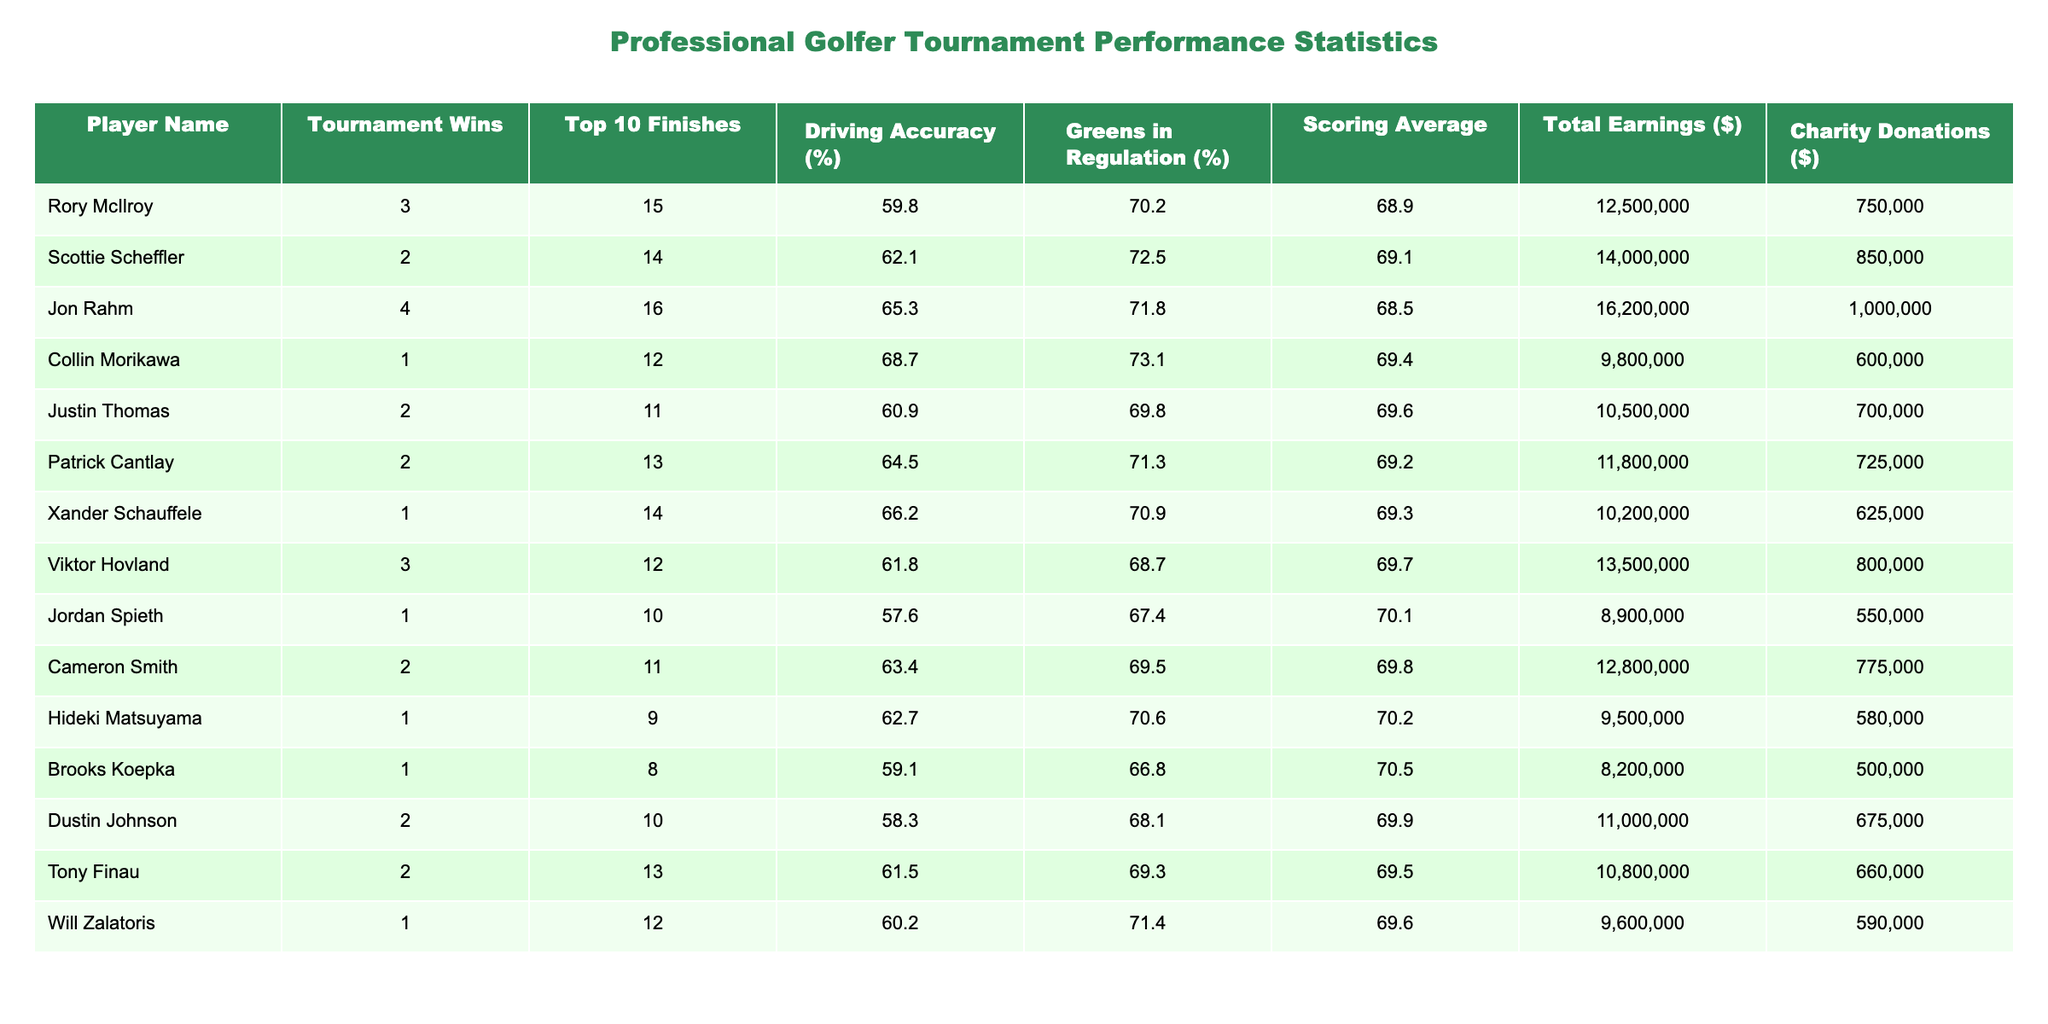What is the player with the highest total earnings? By examining the "Total Earnings ($)" column, Jon Rahm has the highest amount at $16,200,000.
Answer: Jon Rahm How many tournaments did Collin Morikawa win last year? The "Tournament Wins" column for Collin Morikawa shows that he won 1 tournament.
Answer: 1 Which player has the lowest driving accuracy percentage? The "Driving Accuracy (%)" column indicates that Jordan Spieth has the lowest percentage at 57.6%.
Answer: Jordan Spieth What is the average number of charity donations among all players? To find the average, add up all donations ($750,000 + $850,000 + $1,000,000 + $600,000 + $700,000 + $725,000 + $625,000 + $800,000 + $550,000 + $775,000 + $580,000 + $500,000 + $675,000 + $660,000 + $590,000) = $11,725,000. There are 14 players, so $11,725,000 / 14 = $838,214.29, rounded to $838,214.
Answer: $838,214 Did Xander Schauffele finish in the top 10 more times than Collin Morikawa? Xander Schauffele had 14 top 10 finishes while Collin Morikawa had 12. Since 14 is greater than 12, the answer is yes.
Answer: Yes Which player contributed the most to charity among those with three tournament wins? Both Rory McIlroy and Viktor Hovland have three tournament wins. Checking their charity donations, Rory McIlroy donated $750,000, while Viktor Hovland donated $800,000. Thus, Viktor Hovland contributed the most.
Answer: Viktor Hovland What percentage of tournaments won by Jon Rahm corresponds to his total number of tournaments played based on his top 10 finishes? Jon Rahm won 4 tournaments and had 16 top 10 finishes. The percentage of his wins compared to his finishes is (4/16) * 100 = 25%.
Answer: 25% Is there any player who has both a tournament win and a top 10 finish above 15? Checking the table, Jon Rahm has 4 wins and 16 top 10 finishes, fulfilling this criteria.
Answer: Yes What is the scoring average of the player with the highest number of top 10 finishes? Jon Rahm also has the highest number of top 10 finishes at 16, and his scoring average is 68.5.
Answer: 68.5 How many more top 10 finishes does Scottie Scheffler have compared to Brooks Koepka? Scottie Scheffler has 14 top 10 finishes and Brooks Koepka has 8. Thus, the difference is 14 - 8 = 6.
Answer: 6 What is the total combined earnings of players who each won 2 tournaments? The players with 2 wins are Scottie Scheffler, Justin Thomas, Patrick Cantlay, Cameron Smith, and Tony Finau. Their total earnings are: $14,000,000 + $10,500,000 + $11,800,000 + $12,800,000 + $10,800,000 = $60,900,000.
Answer: $60,900,000 